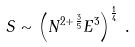<formula> <loc_0><loc_0><loc_500><loc_500>S \sim \left ( N ^ { 2 + \frac { 3 } { 5 } } E ^ { 3 } \right ) ^ { \frac { 1 } { 4 } } \, .</formula> 